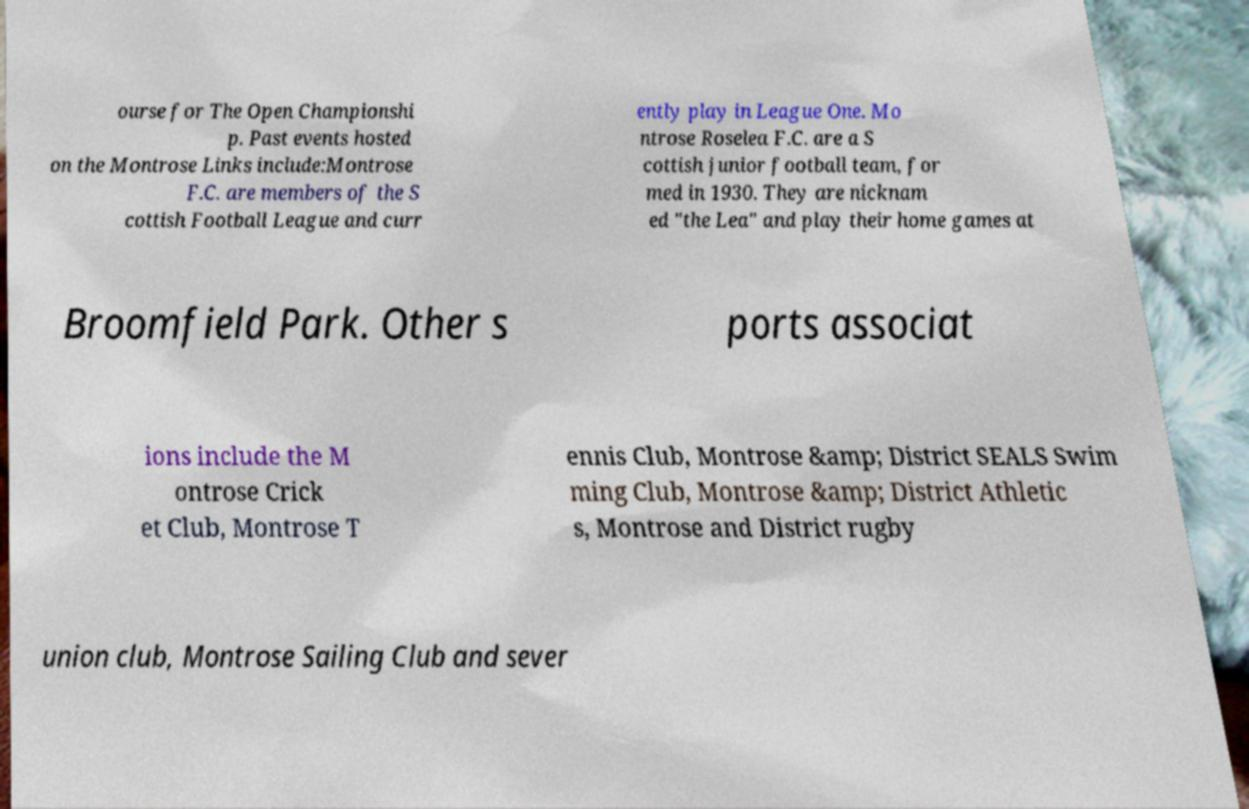For documentation purposes, I need the text within this image transcribed. Could you provide that? ourse for The Open Championshi p. Past events hosted on the Montrose Links include:Montrose F.C. are members of the S cottish Football League and curr ently play in League One. Mo ntrose Roselea F.C. are a S cottish junior football team, for med in 1930. They are nicknam ed "the Lea" and play their home games at Broomfield Park. Other s ports associat ions include the M ontrose Crick et Club, Montrose T ennis Club, Montrose &amp; District SEALS Swim ming Club, Montrose &amp; District Athletic s, Montrose and District rugby union club, Montrose Sailing Club and sever 